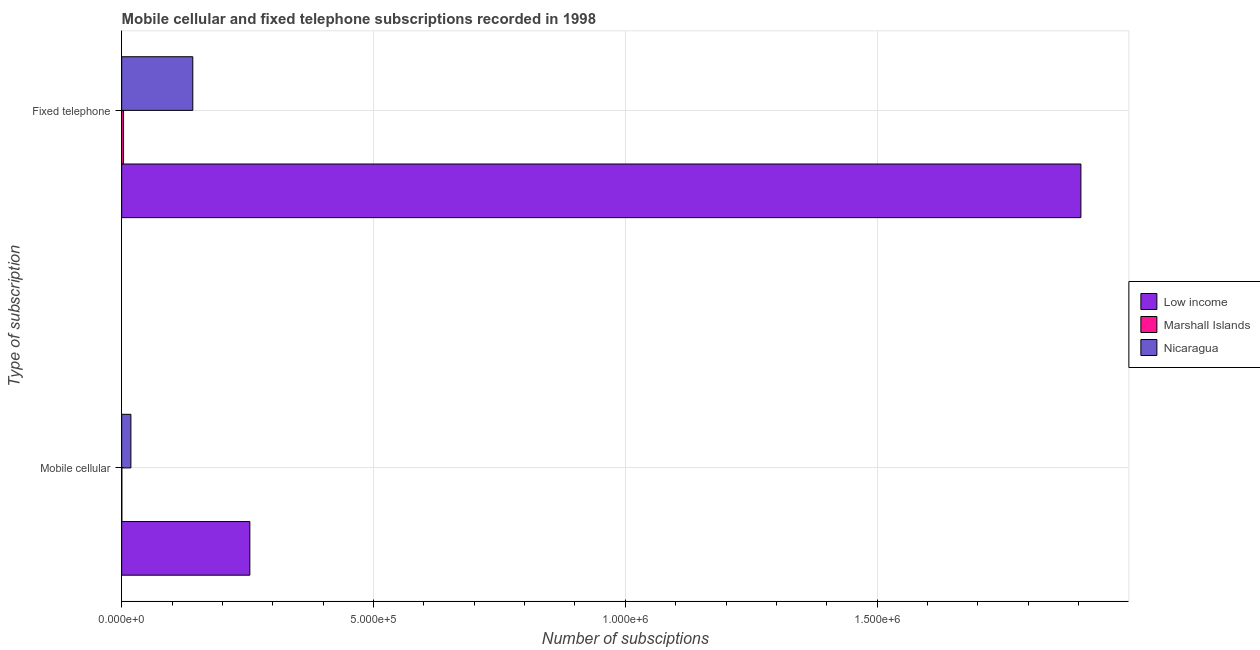How many different coloured bars are there?
Give a very brief answer. 3. How many groups of bars are there?
Make the answer very short. 2. Are the number of bars per tick equal to the number of legend labels?
Provide a short and direct response. Yes. Are the number of bars on each tick of the Y-axis equal?
Keep it short and to the point. Yes. How many bars are there on the 1st tick from the bottom?
Give a very brief answer. 3. What is the label of the 1st group of bars from the top?
Your response must be concise. Fixed telephone. What is the number of fixed telephone subscriptions in Nicaragua?
Provide a short and direct response. 1.41e+05. Across all countries, what is the maximum number of mobile cellular subscriptions?
Give a very brief answer. 2.54e+05. Across all countries, what is the minimum number of fixed telephone subscriptions?
Your answer should be very brief. 3744. In which country was the number of mobile cellular subscriptions maximum?
Give a very brief answer. Low income. In which country was the number of fixed telephone subscriptions minimum?
Provide a succinct answer. Marshall Islands. What is the total number of mobile cellular subscriptions in the graph?
Offer a very short reply. 2.73e+05. What is the difference between the number of fixed telephone subscriptions in Marshall Islands and that in Low income?
Make the answer very short. -1.90e+06. What is the difference between the number of mobile cellular subscriptions in Low income and the number of fixed telephone subscriptions in Marshall Islands?
Provide a short and direct response. 2.51e+05. What is the average number of mobile cellular subscriptions per country?
Keep it short and to the point. 9.11e+04. What is the difference between the number of fixed telephone subscriptions and number of mobile cellular subscriptions in Low income?
Provide a succinct answer. 1.65e+06. What is the ratio of the number of fixed telephone subscriptions in Low income to that in Nicaragua?
Your answer should be compact. 13.49. What does the 2nd bar from the top in Mobile cellular represents?
Offer a very short reply. Marshall Islands. What does the 3rd bar from the bottom in Fixed telephone represents?
Make the answer very short. Nicaragua. Are all the bars in the graph horizontal?
Offer a terse response. Yes. How many countries are there in the graph?
Make the answer very short. 3. Does the graph contain grids?
Provide a short and direct response. Yes. Where does the legend appear in the graph?
Make the answer very short. Center right. How many legend labels are there?
Provide a succinct answer. 3. What is the title of the graph?
Your response must be concise. Mobile cellular and fixed telephone subscriptions recorded in 1998. What is the label or title of the X-axis?
Offer a very short reply. Number of subsciptions. What is the label or title of the Y-axis?
Offer a very short reply. Type of subscription. What is the Number of subsciptions in Low income in Mobile cellular?
Your answer should be very brief. 2.54e+05. What is the Number of subsciptions in Marshall Islands in Mobile cellular?
Give a very brief answer. 345. What is the Number of subsciptions in Nicaragua in Mobile cellular?
Provide a short and direct response. 1.83e+04. What is the Number of subsciptions of Low income in Fixed telephone?
Your answer should be compact. 1.90e+06. What is the Number of subsciptions in Marshall Islands in Fixed telephone?
Ensure brevity in your answer.  3744. What is the Number of subsciptions in Nicaragua in Fixed telephone?
Provide a succinct answer. 1.41e+05. Across all Type of subscription, what is the maximum Number of subsciptions of Low income?
Your answer should be compact. 1.90e+06. Across all Type of subscription, what is the maximum Number of subsciptions of Marshall Islands?
Offer a very short reply. 3744. Across all Type of subscription, what is the maximum Number of subsciptions of Nicaragua?
Your response must be concise. 1.41e+05. Across all Type of subscription, what is the minimum Number of subsciptions in Low income?
Offer a very short reply. 2.54e+05. Across all Type of subscription, what is the minimum Number of subsciptions of Marshall Islands?
Make the answer very short. 345. Across all Type of subscription, what is the minimum Number of subsciptions of Nicaragua?
Your response must be concise. 1.83e+04. What is the total Number of subsciptions in Low income in the graph?
Ensure brevity in your answer.  2.16e+06. What is the total Number of subsciptions in Marshall Islands in the graph?
Your answer should be very brief. 4089. What is the total Number of subsciptions of Nicaragua in the graph?
Ensure brevity in your answer.  1.60e+05. What is the difference between the Number of subsciptions of Low income in Mobile cellular and that in Fixed telephone?
Keep it short and to the point. -1.65e+06. What is the difference between the Number of subsciptions in Marshall Islands in Mobile cellular and that in Fixed telephone?
Offer a terse response. -3399. What is the difference between the Number of subsciptions of Nicaragua in Mobile cellular and that in Fixed telephone?
Provide a succinct answer. -1.23e+05. What is the difference between the Number of subsciptions in Low income in Mobile cellular and the Number of subsciptions in Marshall Islands in Fixed telephone?
Your response must be concise. 2.51e+05. What is the difference between the Number of subsciptions of Low income in Mobile cellular and the Number of subsciptions of Nicaragua in Fixed telephone?
Offer a terse response. 1.13e+05. What is the difference between the Number of subsciptions in Marshall Islands in Mobile cellular and the Number of subsciptions in Nicaragua in Fixed telephone?
Keep it short and to the point. -1.41e+05. What is the average Number of subsciptions of Low income per Type of subscription?
Give a very brief answer. 1.08e+06. What is the average Number of subsciptions of Marshall Islands per Type of subscription?
Provide a short and direct response. 2044.5. What is the average Number of subsciptions of Nicaragua per Type of subscription?
Ensure brevity in your answer.  7.98e+04. What is the difference between the Number of subsciptions of Low income and Number of subsciptions of Marshall Islands in Mobile cellular?
Keep it short and to the point. 2.54e+05. What is the difference between the Number of subsciptions of Low income and Number of subsciptions of Nicaragua in Mobile cellular?
Offer a very short reply. 2.36e+05. What is the difference between the Number of subsciptions in Marshall Islands and Number of subsciptions in Nicaragua in Mobile cellular?
Your answer should be very brief. -1.80e+04. What is the difference between the Number of subsciptions in Low income and Number of subsciptions in Marshall Islands in Fixed telephone?
Your response must be concise. 1.90e+06. What is the difference between the Number of subsciptions of Low income and Number of subsciptions of Nicaragua in Fixed telephone?
Keep it short and to the point. 1.76e+06. What is the difference between the Number of subsciptions in Marshall Islands and Number of subsciptions in Nicaragua in Fixed telephone?
Give a very brief answer. -1.37e+05. What is the ratio of the Number of subsciptions in Low income in Mobile cellular to that in Fixed telephone?
Make the answer very short. 0.13. What is the ratio of the Number of subsciptions of Marshall Islands in Mobile cellular to that in Fixed telephone?
Offer a very short reply. 0.09. What is the ratio of the Number of subsciptions in Nicaragua in Mobile cellular to that in Fixed telephone?
Offer a very short reply. 0.13. What is the difference between the highest and the second highest Number of subsciptions of Low income?
Provide a succinct answer. 1.65e+06. What is the difference between the highest and the second highest Number of subsciptions of Marshall Islands?
Your answer should be very brief. 3399. What is the difference between the highest and the second highest Number of subsciptions of Nicaragua?
Your answer should be compact. 1.23e+05. What is the difference between the highest and the lowest Number of subsciptions in Low income?
Make the answer very short. 1.65e+06. What is the difference between the highest and the lowest Number of subsciptions in Marshall Islands?
Your answer should be very brief. 3399. What is the difference between the highest and the lowest Number of subsciptions in Nicaragua?
Offer a terse response. 1.23e+05. 